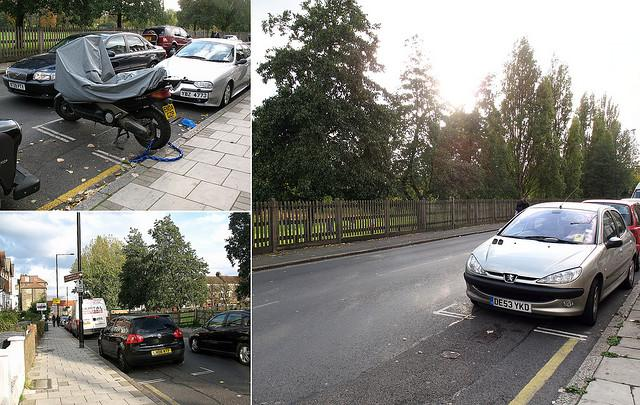What does the grey cloth do? protect 